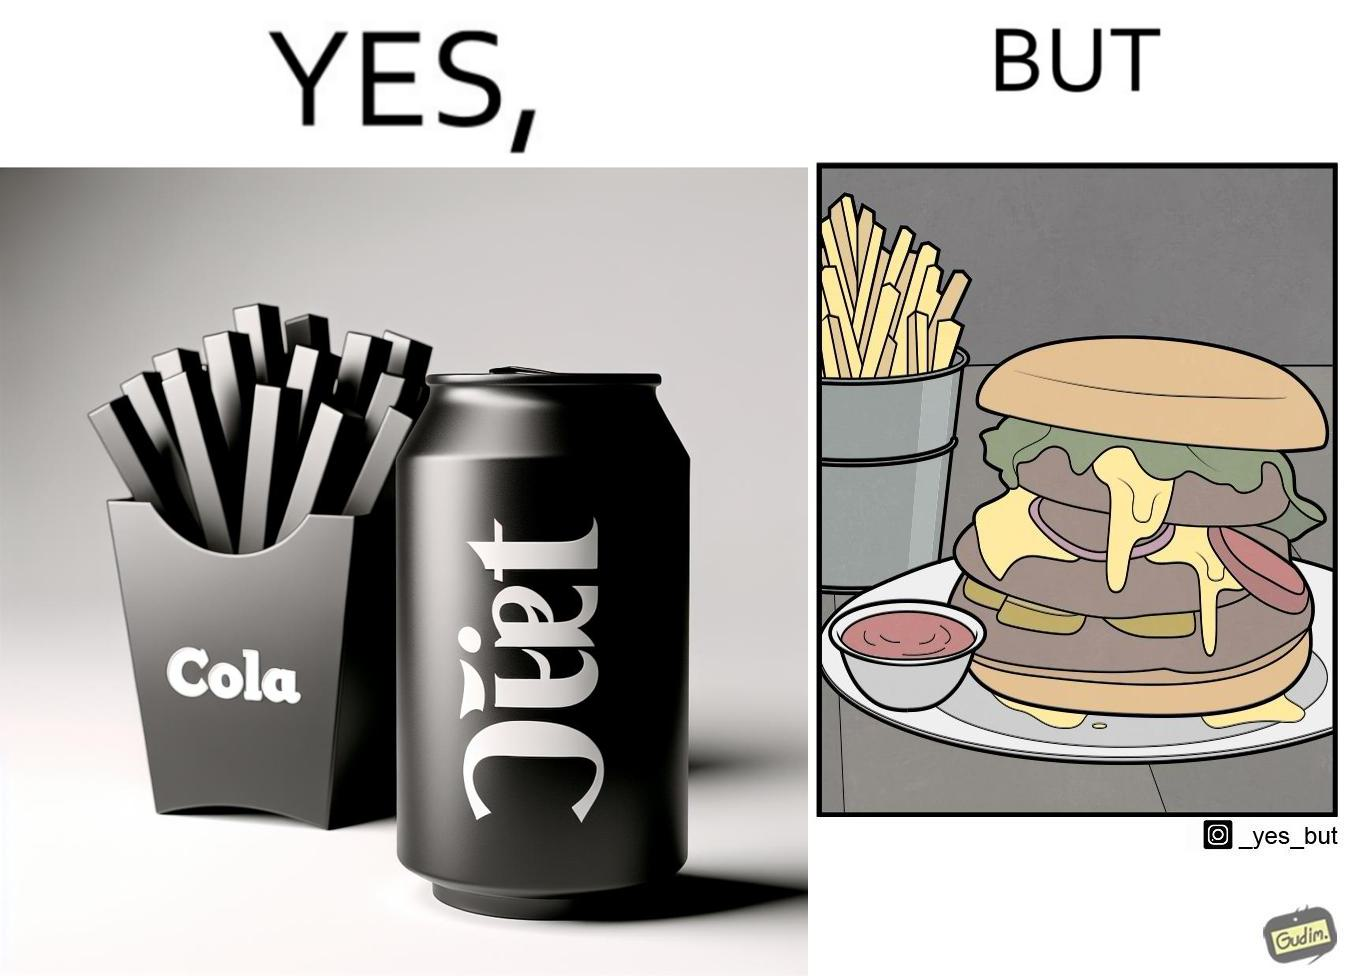What makes this image funny or satirical? The image is ironic, because on one hand the person is consuming diet cola suggesting low on sugar as per label meaning the person is health-conscious but on the other hand the same one is having huge size burger with french fries which suggests the person to be health-ignorant 